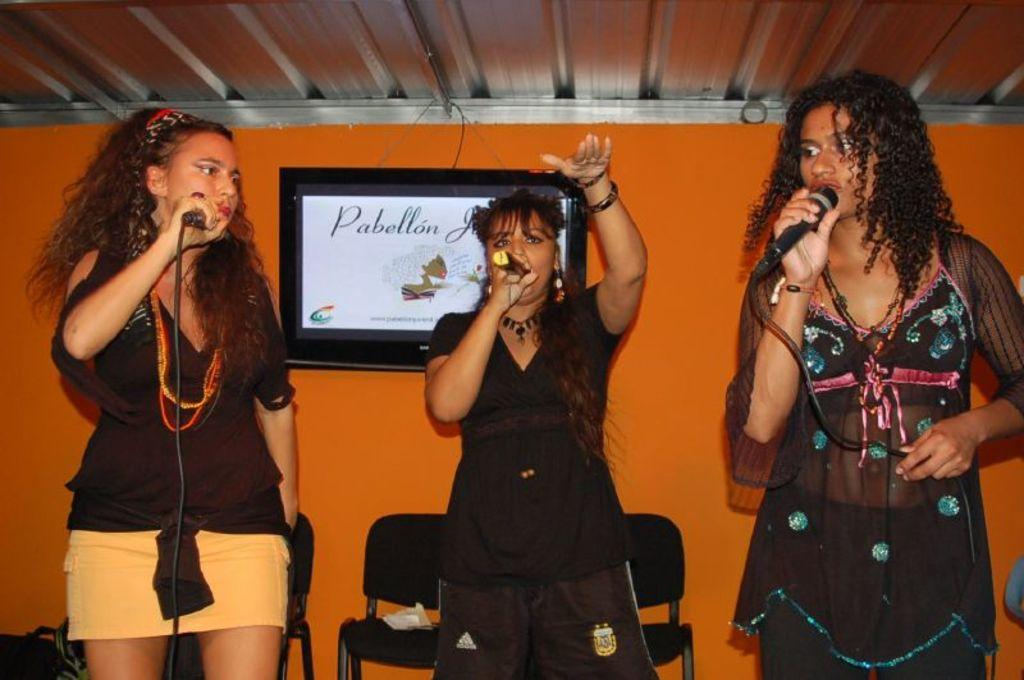How many women are in the image? There are three women in the image. What are the women wearing? The women are wearing black dresses. What are the women holding in their hands? The women are holding microphones. What is located behind the women? There is a frame behind the women. What type of furniture is at the bottom of the image? There are chairs at the bottom of the image. Can you see any apples on the women's heads in the image? No, there are no apples present in the image, nor are any fruits or objects placed on the women's heads. 